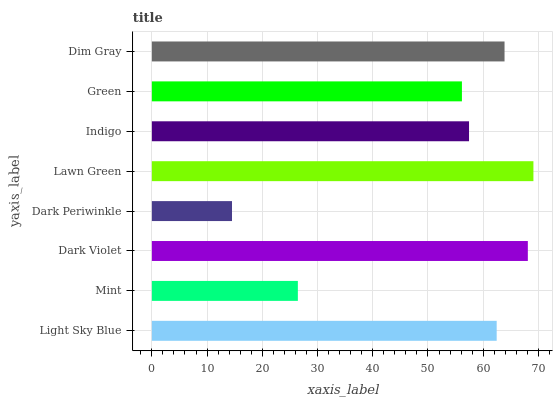Is Dark Periwinkle the minimum?
Answer yes or no. Yes. Is Lawn Green the maximum?
Answer yes or no. Yes. Is Mint the minimum?
Answer yes or no. No. Is Mint the maximum?
Answer yes or no. No. Is Light Sky Blue greater than Mint?
Answer yes or no. Yes. Is Mint less than Light Sky Blue?
Answer yes or no. Yes. Is Mint greater than Light Sky Blue?
Answer yes or no. No. Is Light Sky Blue less than Mint?
Answer yes or no. No. Is Light Sky Blue the high median?
Answer yes or no. Yes. Is Indigo the low median?
Answer yes or no. Yes. Is Lawn Green the high median?
Answer yes or no. No. Is Dark Violet the low median?
Answer yes or no. No. 